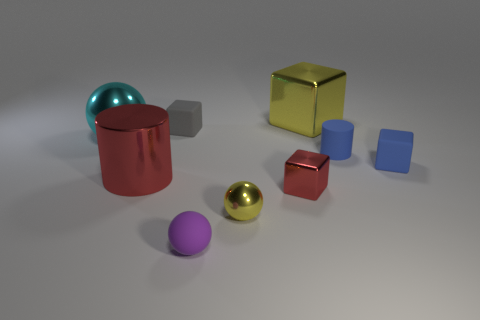There is a tiny sphere that is the same color as the large metallic block; what material is it?
Keep it short and to the point. Metal. There is a object that is the same color as the big metal cylinder; what is its shape?
Make the answer very short. Cube. Is the number of purple cylinders greater than the number of big cyan metallic spheres?
Give a very brief answer. No. How big is the yellow thing that is on the left side of the red shiny thing to the right of the tiny rubber object in front of the large red object?
Ensure brevity in your answer.  Small. There is a yellow shiny cube; is it the same size as the yellow metal object in front of the tiny red object?
Make the answer very short. No. Are there fewer large cyan metallic things right of the yellow metallic block than metal things?
Give a very brief answer. Yes. How many big metal spheres have the same color as the tiny metal ball?
Your answer should be very brief. 0. Are there fewer big cyan shiny things than metal blocks?
Make the answer very short. Yes. Are the yellow block and the large cyan sphere made of the same material?
Your answer should be compact. Yes. What number of other things are the same size as the rubber cylinder?
Give a very brief answer. 5. 